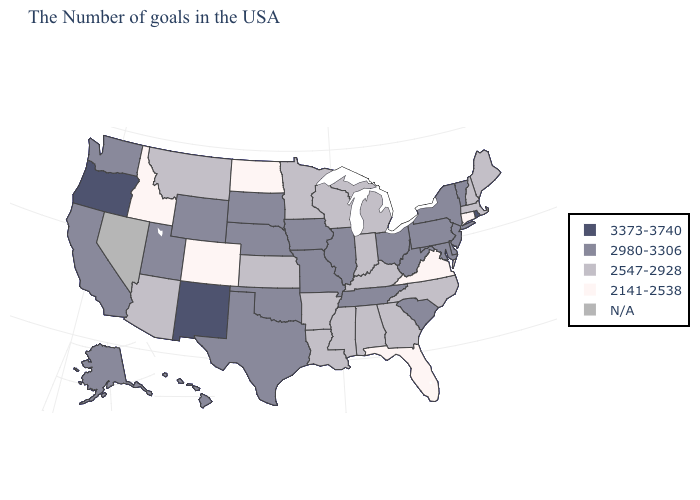Among the states that border Illinois , does Wisconsin have the highest value?
Answer briefly. No. What is the value of Arkansas?
Concise answer only. 2547-2928. What is the value of Georgia?
Be succinct. 2547-2928. What is the lowest value in states that border Washington?
Be succinct. 2141-2538. Which states have the lowest value in the USA?
Write a very short answer. Connecticut, Virginia, Florida, North Dakota, Colorado, Idaho. What is the highest value in the USA?
Give a very brief answer. 3373-3740. What is the value of Louisiana?
Be succinct. 2547-2928. What is the lowest value in the Northeast?
Short answer required. 2141-2538. Which states have the lowest value in the South?
Be succinct. Virginia, Florida. What is the value of Minnesota?
Quick response, please. 2547-2928. Among the states that border North Carolina , which have the highest value?
Keep it brief. South Carolina, Tennessee. What is the lowest value in the South?
Short answer required. 2141-2538. What is the value of Illinois?
Be succinct. 2980-3306. Name the states that have a value in the range N/A?
Answer briefly. Nevada. Which states have the lowest value in the USA?
Concise answer only. Connecticut, Virginia, Florida, North Dakota, Colorado, Idaho. 